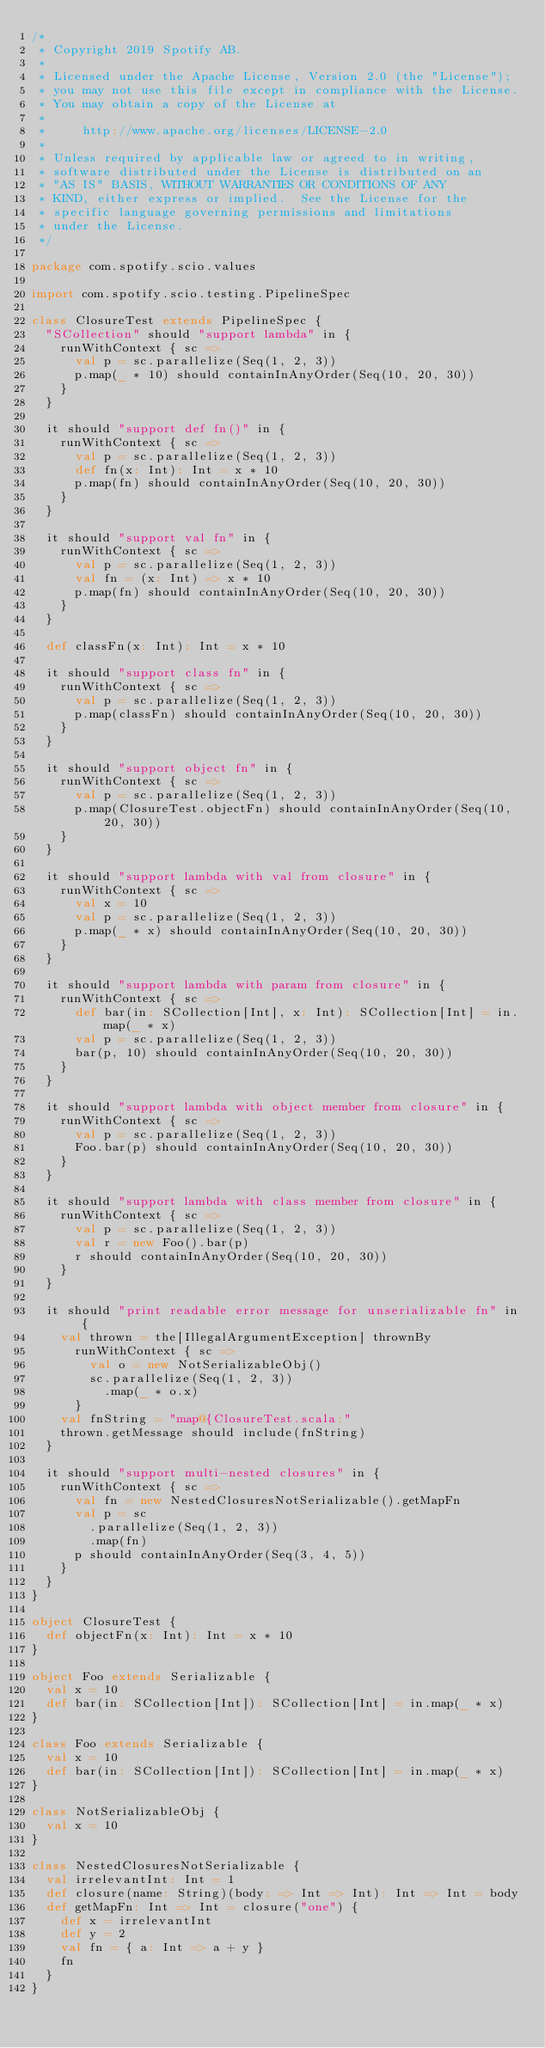<code> <loc_0><loc_0><loc_500><loc_500><_Scala_>/*
 * Copyright 2019 Spotify AB.
 *
 * Licensed under the Apache License, Version 2.0 (the "License");
 * you may not use this file except in compliance with the License.
 * You may obtain a copy of the License at
 *
 *     http://www.apache.org/licenses/LICENSE-2.0
 *
 * Unless required by applicable law or agreed to in writing,
 * software distributed under the License is distributed on an
 * "AS IS" BASIS, WITHOUT WARRANTIES OR CONDITIONS OF ANY
 * KIND, either express or implied.  See the License for the
 * specific language governing permissions and limitations
 * under the License.
 */

package com.spotify.scio.values

import com.spotify.scio.testing.PipelineSpec

class ClosureTest extends PipelineSpec {
  "SCollection" should "support lambda" in {
    runWithContext { sc =>
      val p = sc.parallelize(Seq(1, 2, 3))
      p.map(_ * 10) should containInAnyOrder(Seq(10, 20, 30))
    }
  }

  it should "support def fn()" in {
    runWithContext { sc =>
      val p = sc.parallelize(Seq(1, 2, 3))
      def fn(x: Int): Int = x * 10
      p.map(fn) should containInAnyOrder(Seq(10, 20, 30))
    }
  }

  it should "support val fn" in {
    runWithContext { sc =>
      val p = sc.parallelize(Seq(1, 2, 3))
      val fn = (x: Int) => x * 10
      p.map(fn) should containInAnyOrder(Seq(10, 20, 30))
    }
  }

  def classFn(x: Int): Int = x * 10

  it should "support class fn" in {
    runWithContext { sc =>
      val p = sc.parallelize(Seq(1, 2, 3))
      p.map(classFn) should containInAnyOrder(Seq(10, 20, 30))
    }
  }

  it should "support object fn" in {
    runWithContext { sc =>
      val p = sc.parallelize(Seq(1, 2, 3))
      p.map(ClosureTest.objectFn) should containInAnyOrder(Seq(10, 20, 30))
    }
  }

  it should "support lambda with val from closure" in {
    runWithContext { sc =>
      val x = 10
      val p = sc.parallelize(Seq(1, 2, 3))
      p.map(_ * x) should containInAnyOrder(Seq(10, 20, 30))
    }
  }

  it should "support lambda with param from closure" in {
    runWithContext { sc =>
      def bar(in: SCollection[Int], x: Int): SCollection[Int] = in.map(_ * x)
      val p = sc.parallelize(Seq(1, 2, 3))
      bar(p, 10) should containInAnyOrder(Seq(10, 20, 30))
    }
  }

  it should "support lambda with object member from closure" in {
    runWithContext { sc =>
      val p = sc.parallelize(Seq(1, 2, 3))
      Foo.bar(p) should containInAnyOrder(Seq(10, 20, 30))
    }
  }

  it should "support lambda with class member from closure" in {
    runWithContext { sc =>
      val p = sc.parallelize(Seq(1, 2, 3))
      val r = new Foo().bar(p)
      r should containInAnyOrder(Seq(10, 20, 30))
    }
  }

  it should "print readable error message for unserializable fn" in {
    val thrown = the[IllegalArgumentException] thrownBy
      runWithContext { sc =>
        val o = new NotSerializableObj()
        sc.parallelize(Seq(1, 2, 3))
          .map(_ * o.x)
      }
    val fnString = "map@{ClosureTest.scala:"
    thrown.getMessage should include(fnString)
  }

  it should "support multi-nested closures" in {
    runWithContext { sc =>
      val fn = new NestedClosuresNotSerializable().getMapFn
      val p = sc
        .parallelize(Seq(1, 2, 3))
        .map(fn)
      p should containInAnyOrder(Seq(3, 4, 5))
    }
  }
}

object ClosureTest {
  def objectFn(x: Int): Int = x * 10
}

object Foo extends Serializable {
  val x = 10
  def bar(in: SCollection[Int]): SCollection[Int] = in.map(_ * x)
}

class Foo extends Serializable {
  val x = 10
  def bar(in: SCollection[Int]): SCollection[Int] = in.map(_ * x)
}

class NotSerializableObj {
  val x = 10
}

class NestedClosuresNotSerializable {
  val irrelevantInt: Int = 1
  def closure(name: String)(body: => Int => Int): Int => Int = body
  def getMapFn: Int => Int = closure("one") {
    def x = irrelevantInt
    def y = 2
    val fn = { a: Int => a + y }
    fn
  }
}
</code> 